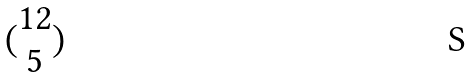<formula> <loc_0><loc_0><loc_500><loc_500>( \begin{matrix} 1 2 \\ 5 \end{matrix} )</formula> 